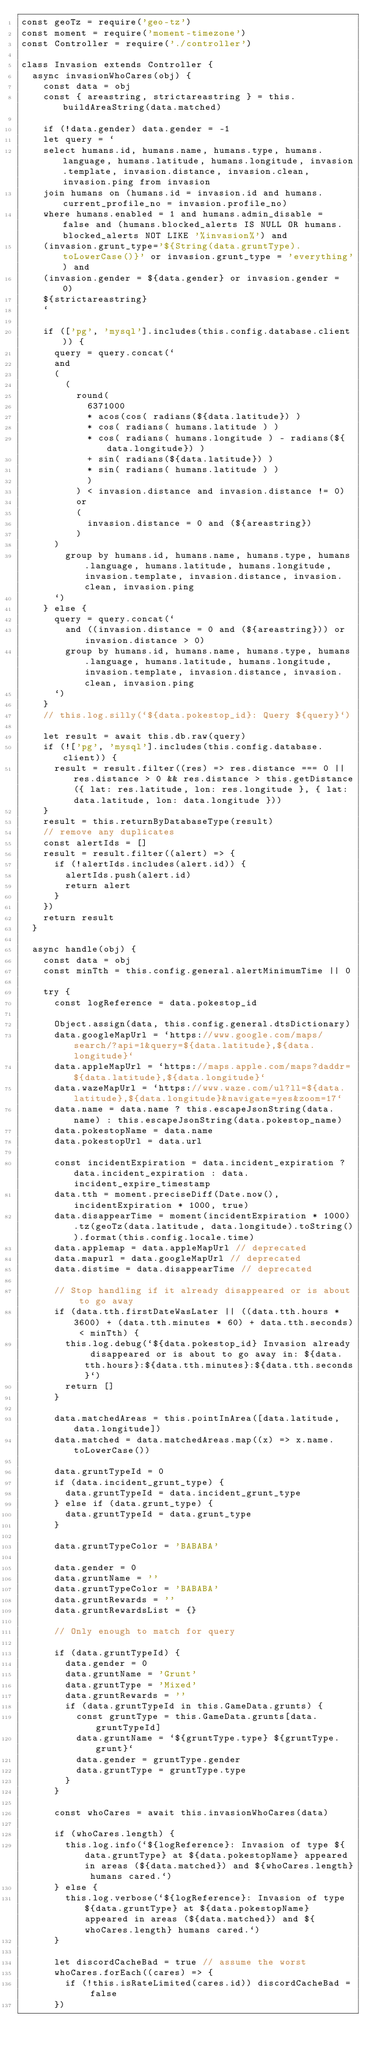Convert code to text. <code><loc_0><loc_0><loc_500><loc_500><_JavaScript_>const geoTz = require('geo-tz')
const moment = require('moment-timezone')
const Controller = require('./controller')

class Invasion extends Controller {
	async invasionWhoCares(obj) {
		const data = obj
		const { areastring, strictareastring } = this.buildAreaString(data.matched)

		if (!data.gender) data.gender = -1
		let query = `
		select humans.id, humans.name, humans.type, humans.language, humans.latitude, humans.longitude, invasion.template, invasion.distance, invasion.clean, invasion.ping from invasion
		join humans on (humans.id = invasion.id and humans.current_profile_no = invasion.profile_no)
		where humans.enabled = 1 and humans.admin_disable = false and (humans.blocked_alerts IS NULL OR humans.blocked_alerts NOT LIKE '%invasion%') and
		(invasion.grunt_type='${String(data.gruntType).toLowerCase()}' or invasion.grunt_type = 'everything') and
		(invasion.gender = ${data.gender} or invasion.gender = 0)
		${strictareastring}
		`

		if (['pg', 'mysql'].includes(this.config.database.client)) {
			query = query.concat(`
			and
			(
				(
					round(
						6371000
						* acos(cos( radians(${data.latitude}) )
						* cos( radians( humans.latitude ) )
						* cos( radians( humans.longitude ) - radians(${data.longitude}) )
						+ sin( radians(${data.latitude}) )
						* sin( radians( humans.latitude ) )
						)
					) < invasion.distance and invasion.distance != 0)
					or
					(
						invasion.distance = 0 and (${areastring})
					)
			)
				group by humans.id, humans.name, humans.type, humans.language, humans.latitude, humans.longitude, invasion.template, invasion.distance, invasion.clean, invasion.ping
			`)
		} else {
			query = query.concat(`
				and ((invasion.distance = 0 and (${areastring})) or invasion.distance > 0)
				group by humans.id, humans.name, humans.type, humans.language, humans.latitude, humans.longitude, invasion.template, invasion.distance, invasion.clean, invasion.ping
			`)
		}
		// this.log.silly(`${data.pokestop_id}: Query ${query}`)

		let result = await this.db.raw(query)
		if (!['pg', 'mysql'].includes(this.config.database.client)) {
			result = result.filter((res) => res.distance === 0 || res.distance > 0 && res.distance > this.getDistance({ lat: res.latitude, lon: res.longitude }, { lat: data.latitude, lon: data.longitude }))
		}
		result = this.returnByDatabaseType(result)
		// remove any duplicates
		const alertIds = []
		result = result.filter((alert) => {
			if (!alertIds.includes(alert.id)) {
				alertIds.push(alert.id)
				return alert
			}
		})
		return result
	}

	async handle(obj) {
		const data = obj
		const minTth = this.config.general.alertMinimumTime || 0

		try {
			const logReference = data.pokestop_id

			Object.assign(data, this.config.general.dtsDictionary)
			data.googleMapUrl = `https://www.google.com/maps/search/?api=1&query=${data.latitude},${data.longitude}`
			data.appleMapUrl = `https://maps.apple.com/maps?daddr=${data.latitude},${data.longitude}`
			data.wazeMapUrl = `https://www.waze.com/ul?ll=${data.latitude},${data.longitude}&navigate=yes&zoom=17`
			data.name = data.name ? this.escapeJsonString(data.name) : this.escapeJsonString(data.pokestop_name)
			data.pokestopName = data.name
			data.pokestopUrl = data.url

			const incidentExpiration = data.incident_expiration ? data.incident_expiration : data.incident_expire_timestamp
			data.tth = moment.preciseDiff(Date.now(), incidentExpiration * 1000, true)
			data.disappearTime = moment(incidentExpiration * 1000).tz(geoTz(data.latitude, data.longitude).toString()).format(this.config.locale.time)
			data.applemap = data.appleMapUrl // deprecated
			data.mapurl = data.googleMapUrl // deprecated
			data.distime = data.disappearTime // deprecated

			// Stop handling if it already disappeared or is about to go away
			if (data.tth.firstDateWasLater || ((data.tth.hours * 3600) + (data.tth.minutes * 60) + data.tth.seconds) < minTth) {
				this.log.debug(`${data.pokestop_id} Invasion already disappeared or is about to go away in: ${data.tth.hours}:${data.tth.minutes}:${data.tth.seconds}`)
				return []
			}

			data.matchedAreas = this.pointInArea([data.latitude, data.longitude])
			data.matched = data.matchedAreas.map((x) => x.name.toLowerCase())

			data.gruntTypeId = 0
			if (data.incident_grunt_type) {
				data.gruntTypeId = data.incident_grunt_type
			} else if (data.grunt_type) {
				data.gruntTypeId = data.grunt_type
			}

			data.gruntTypeColor = 'BABABA'

			data.gender = 0
			data.gruntName = ''
			data.gruntTypeColor = 'BABABA'
			data.gruntRewards = ''
			data.gruntRewardsList = {}

			// Only enough to match for query

			if (data.gruntTypeId) {
				data.gender = 0
				data.gruntName = 'Grunt'
				data.gruntType = 'Mixed'
				data.gruntRewards = ''
				if (data.gruntTypeId in this.GameData.grunts) {
					const gruntType = this.GameData.grunts[data.gruntTypeId]
					data.gruntName = `${gruntType.type} ${gruntType.grunt}`
					data.gender = gruntType.gender
					data.gruntType = gruntType.type
				}
			}

			const whoCares = await this.invasionWhoCares(data)

			if (whoCares.length) {
				this.log.info(`${logReference}: Invasion of type ${data.gruntType} at ${data.pokestopName} appeared in areas (${data.matched}) and ${whoCares.length} humans cared.`)
			} else {
				this.log.verbose(`${logReference}: Invasion of type ${data.gruntType} at ${data.pokestopName} appeared in areas (${data.matched}) and ${whoCares.length} humans cared.`)
			}

			let discordCacheBad = true // assume the worst
			whoCares.forEach((cares) => {
				if (!this.isRateLimited(cares.id)) discordCacheBad = false
			})
</code> 